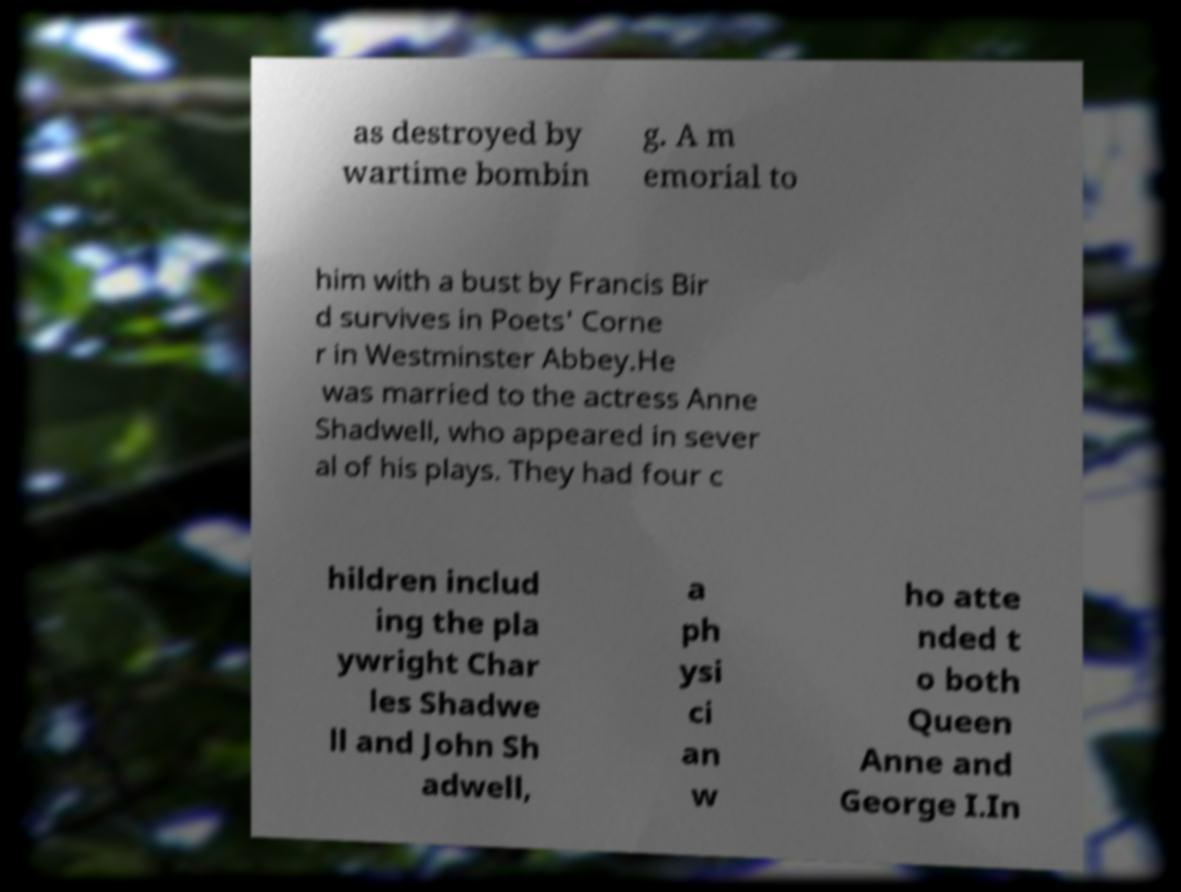Could you assist in decoding the text presented in this image and type it out clearly? as destroyed by wartime bombin g. A m emorial to him with a bust by Francis Bir d survives in Poets' Corne r in Westminster Abbey.He was married to the actress Anne Shadwell, who appeared in sever al of his plays. They had four c hildren includ ing the pla ywright Char les Shadwe ll and John Sh adwell, a ph ysi ci an w ho atte nded t o both Queen Anne and George I.In 